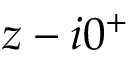Convert formula to latex. <formula><loc_0><loc_0><loc_500><loc_500>z - i 0 ^ { + }</formula> 